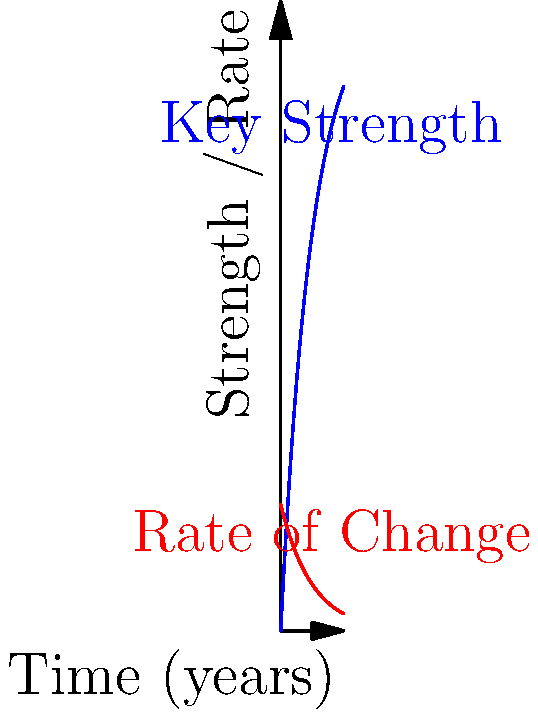The graph shows the encryption key strength $S(t)$ (in arbitrary units) as a function of time $t$ (in years), given by the equation $S(t) = 100(1-e^{-0.2t})$. At what time does the rate of change in key strength equal 10 units per year? To solve this problem, we need to follow these steps:

1) First, we need to find the rate of change of key strength. This is given by the derivative of $S(t)$ with respect to $t$:

   $$\frac{dS}{dt} = 100 \cdot 0.2e^{-0.2t} = 20e^{-0.2t}$$

2) We want to find when this rate equals 10:

   $$20e^{-0.2t} = 10$$

3) Now we solve this equation for $t$:

   $$e^{-0.2t} = \frac{1}{2}$$

4) Taking the natural logarithm of both sides:

   $$-0.2t = \ln(\frac{1}{2}) = -\ln(2)$$

5) Solving for $t$:

   $$t = \frac{\ln(2)}{0.2} \approx 3.47$$

Therefore, the rate of change in key strength equals 10 units per year after approximately 3.47 years.
Answer: 3.47 years 